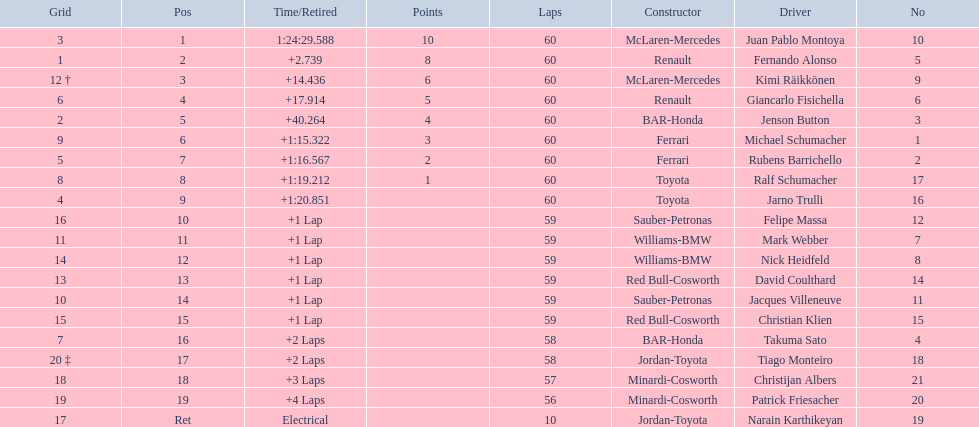Which driver has his grid at 2? Jenson Button. 